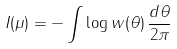<formula> <loc_0><loc_0><loc_500><loc_500>I ( \mu ) = - \int \log w ( \theta ) \, \frac { d \theta } { 2 \pi }</formula> 